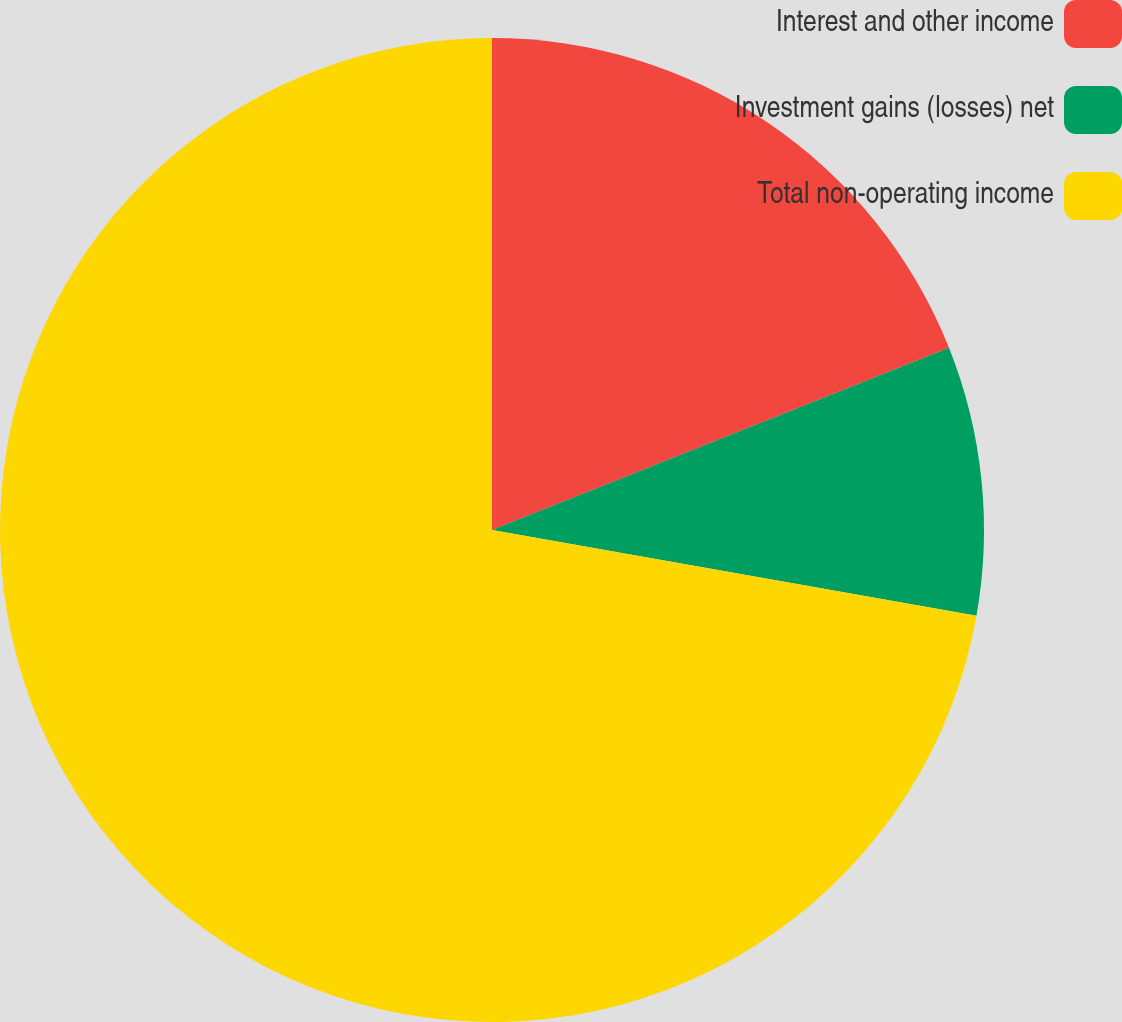Convert chart. <chart><loc_0><loc_0><loc_500><loc_500><pie_chart><fcel>Interest and other income<fcel>Investment gains (losses) net<fcel>Total non-operating income<nl><fcel>18.96%<fcel>8.83%<fcel>72.21%<nl></chart> 